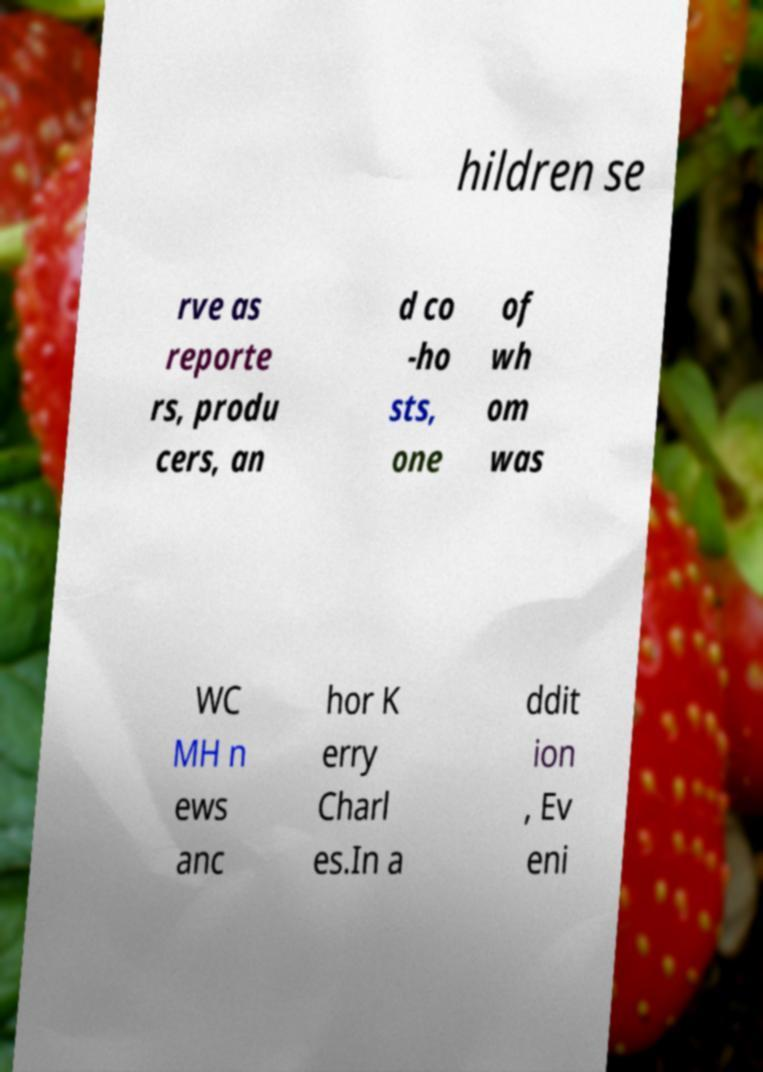For documentation purposes, I need the text within this image transcribed. Could you provide that? hildren se rve as reporte rs, produ cers, an d co -ho sts, one of wh om was WC MH n ews anc hor K erry Charl es.In a ddit ion , Ev eni 